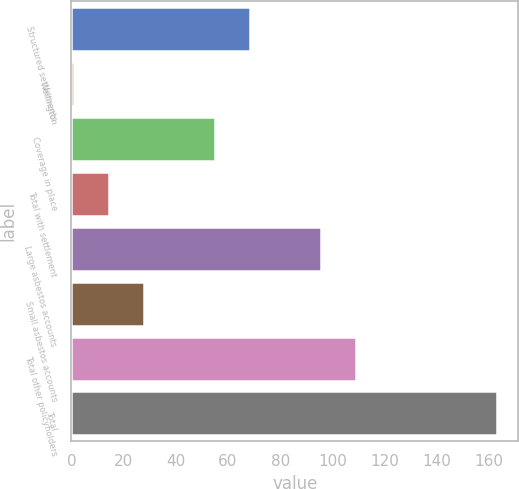Convert chart to OTSL. <chart><loc_0><loc_0><loc_500><loc_500><bar_chart><fcel>Structured settlements<fcel>Wellington<fcel>Coverage in place<fcel>Total with settlement<fcel>Large asbestos accounts<fcel>Small asbestos accounts<fcel>Total other policyholders<fcel>Total<nl><fcel>68.5<fcel>1<fcel>55<fcel>14.5<fcel>95.5<fcel>28<fcel>109<fcel>163<nl></chart> 